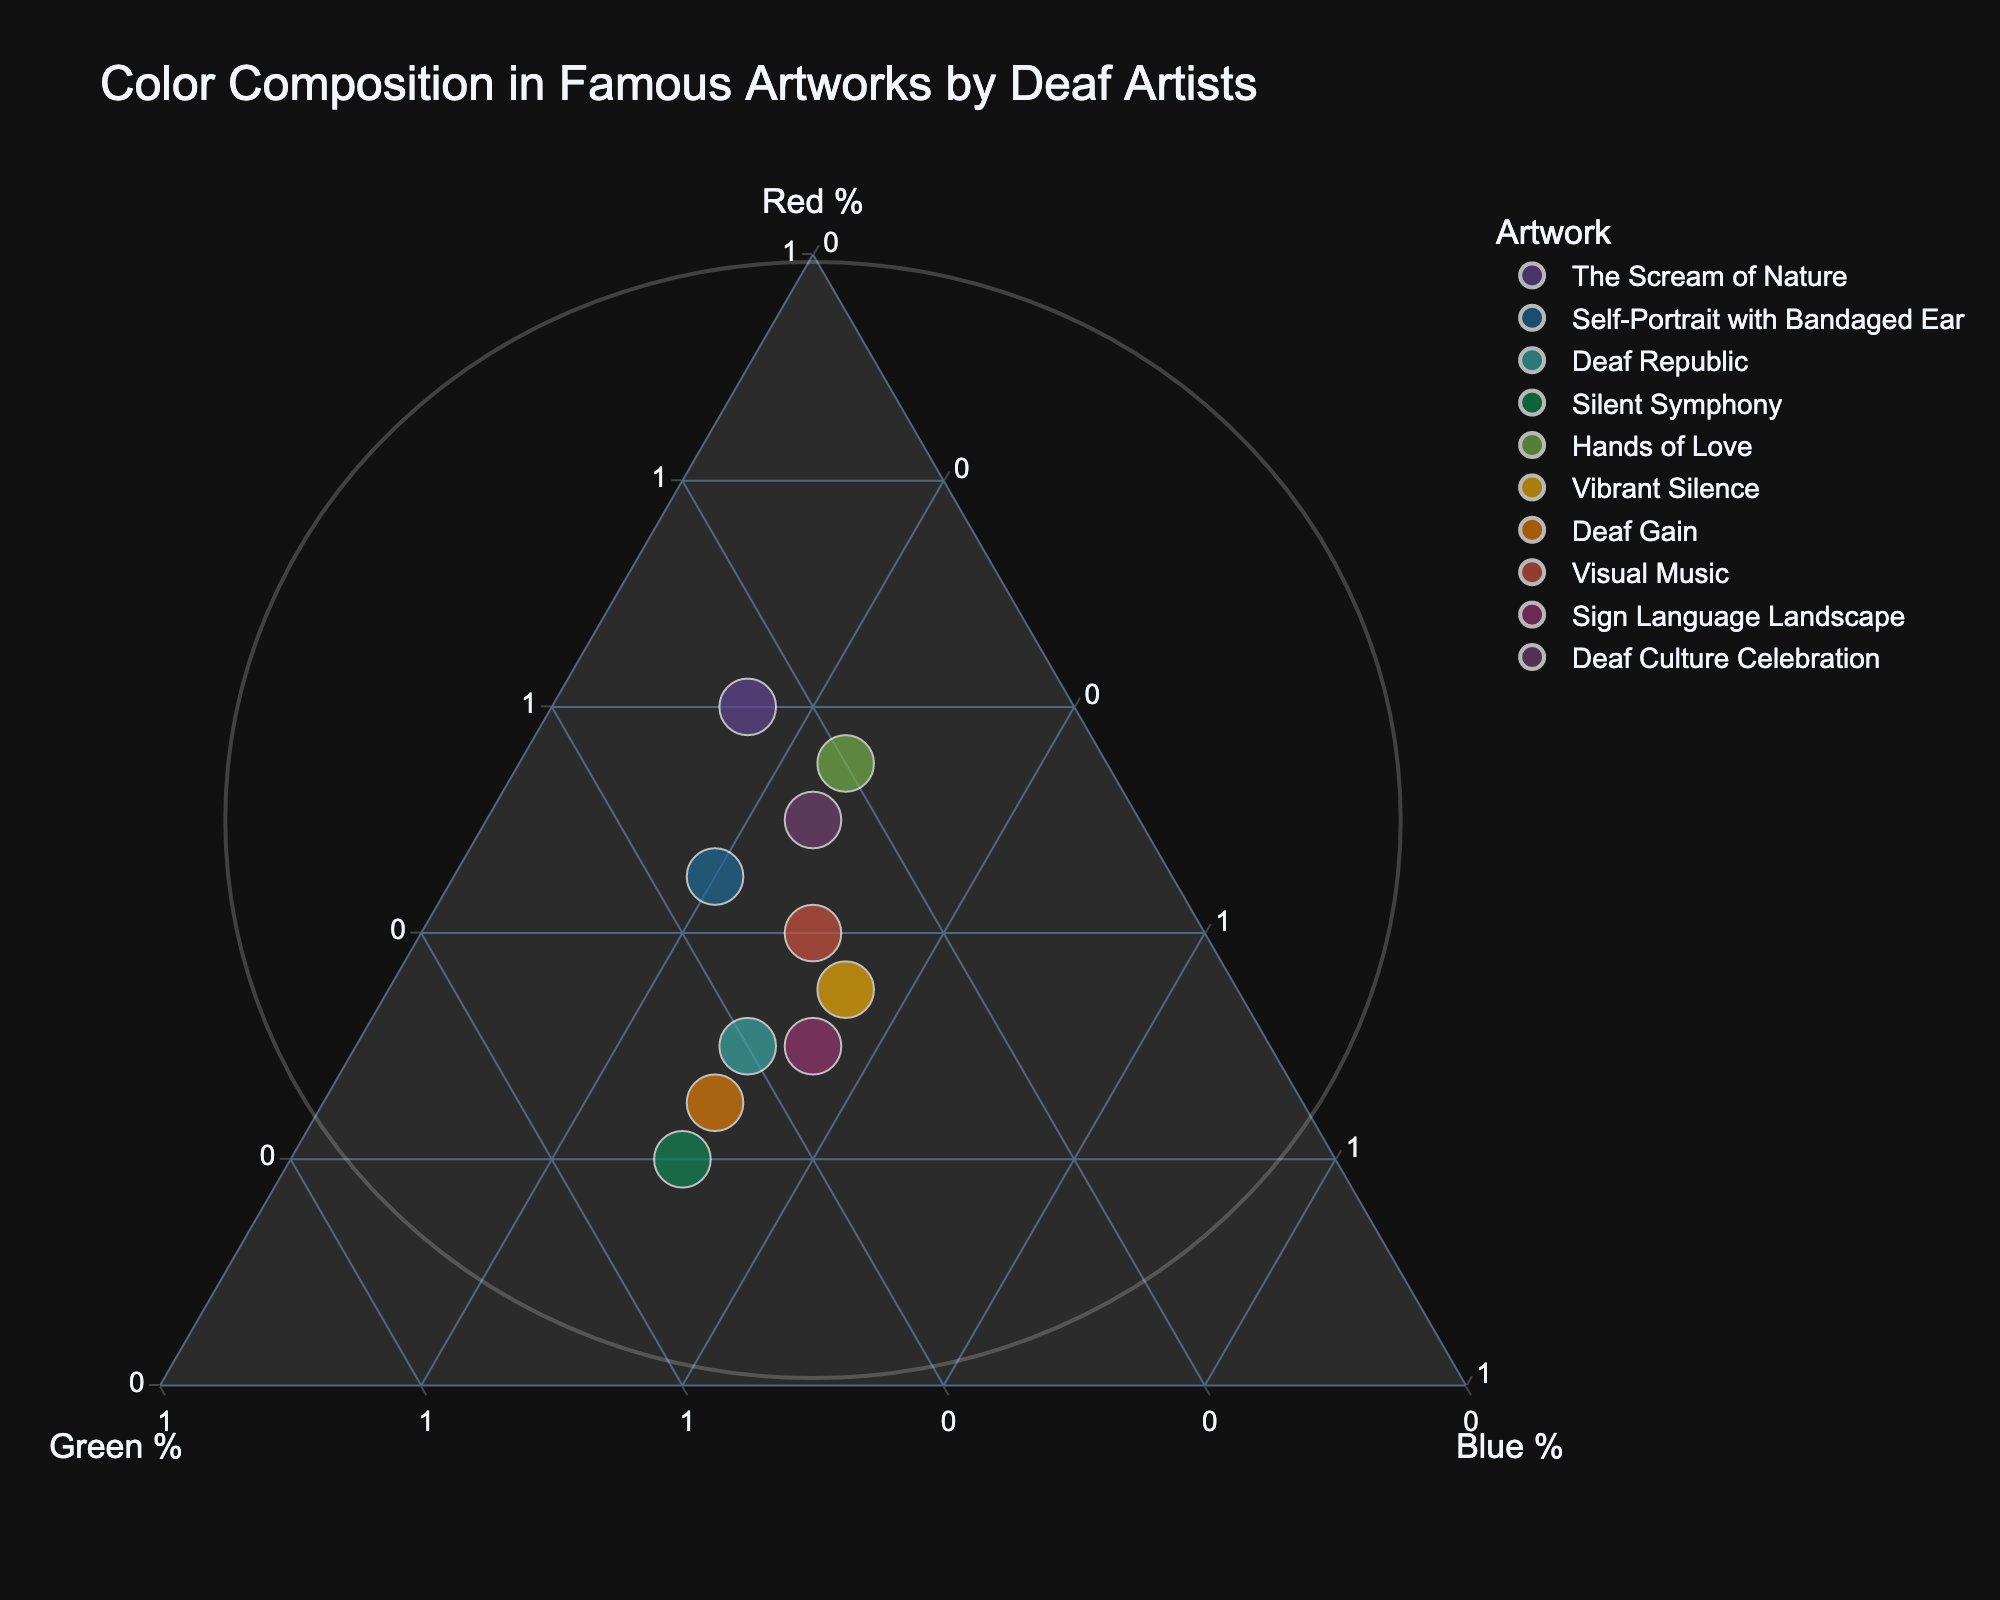What is the title of the figure? The title is usually located at the top of the figure and provides a summary of what the figure represents. In this case, it states "Color Composition in Famous Artworks by Deaf Artists."
Answer: Color Composition in Famous Artworks by Deaf Artists Which artwork has the highest percentage of green? To determine this, locate the highest point on the Green % axis, and match it to the corresponding artwork. "Silent Symphony" has 50% Green, which is the highest.
Answer: Silent Symphony How many artworks have a point inside the circle shape? To answer this, count the number of data points within the circle added to the plot. There are four data points within the circle.
Answer: 4 What's the combination of Red % and Blue % for "The Scream of Nature"? Locate "The Scream of Nature" on the plot and read its coordinates on the Red % and Blue % axes. Red % is 60% and Blue % is 15%.
Answer: 60% Red, 15% Blue Which artwork has balanced color composition, meaning nearly equal percentages of Red, Green, and Blue? Look for a data point close to the center of the plot where Red %, Green %, and Blue % are similar. "Sign Language Landscape" has 30% Red, 35% Green, and 35% Blue, which is quite balanced.
Answer: Sign Language Landscape What's the average percentage of Blue across all artworks? Sum the Blue % values for all artworks and then divide by the total number of artworks: (15+20+30+30+25+35+30+30+35+25)/10 equals 27.5%.
Answer: 27.5% Which artwork is closest to having a dominant Red percentage above 50%? Identify the artwork with a Red percentage slightly above or equal to 50%. "The Scream of Nature" has 60% Red and is the only one significantly above 50%.
Answer: The Scream of Nature Are there any artworks with less than 20% Red? Examine the points in the plot and their corresponding Red % values. "Silent Symphony" has 20% Red, but none have less than 20%.
Answer: No Which artwork has more Green % compared to Blue % and Red %? Compare the Green % values to the Red % and Blue % values. "Deaf Gain" has 45% Green, which is higher compared to its Red (25%) and Blue (30%).
Answer: Deaf Gain What's the range of Red % values observed in the artworks? Identify the minimum and maximum Red % values from the plot: the minimum is 20% from "Silent Symphony" and the maximum is 60% from "The Scream of Nature," so the range is 60% - 20% = 40%.
Answer: 40% 